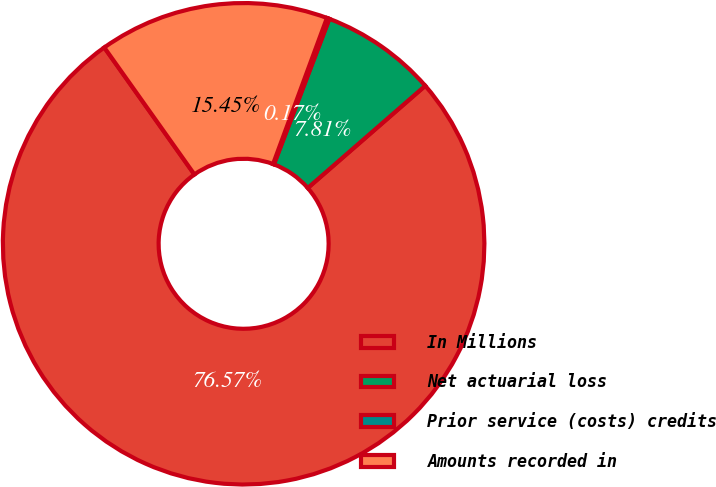Convert chart to OTSL. <chart><loc_0><loc_0><loc_500><loc_500><pie_chart><fcel>In Millions<fcel>Net actuarial loss<fcel>Prior service (costs) credits<fcel>Amounts recorded in<nl><fcel>76.58%<fcel>7.81%<fcel>0.17%<fcel>15.45%<nl></chart> 